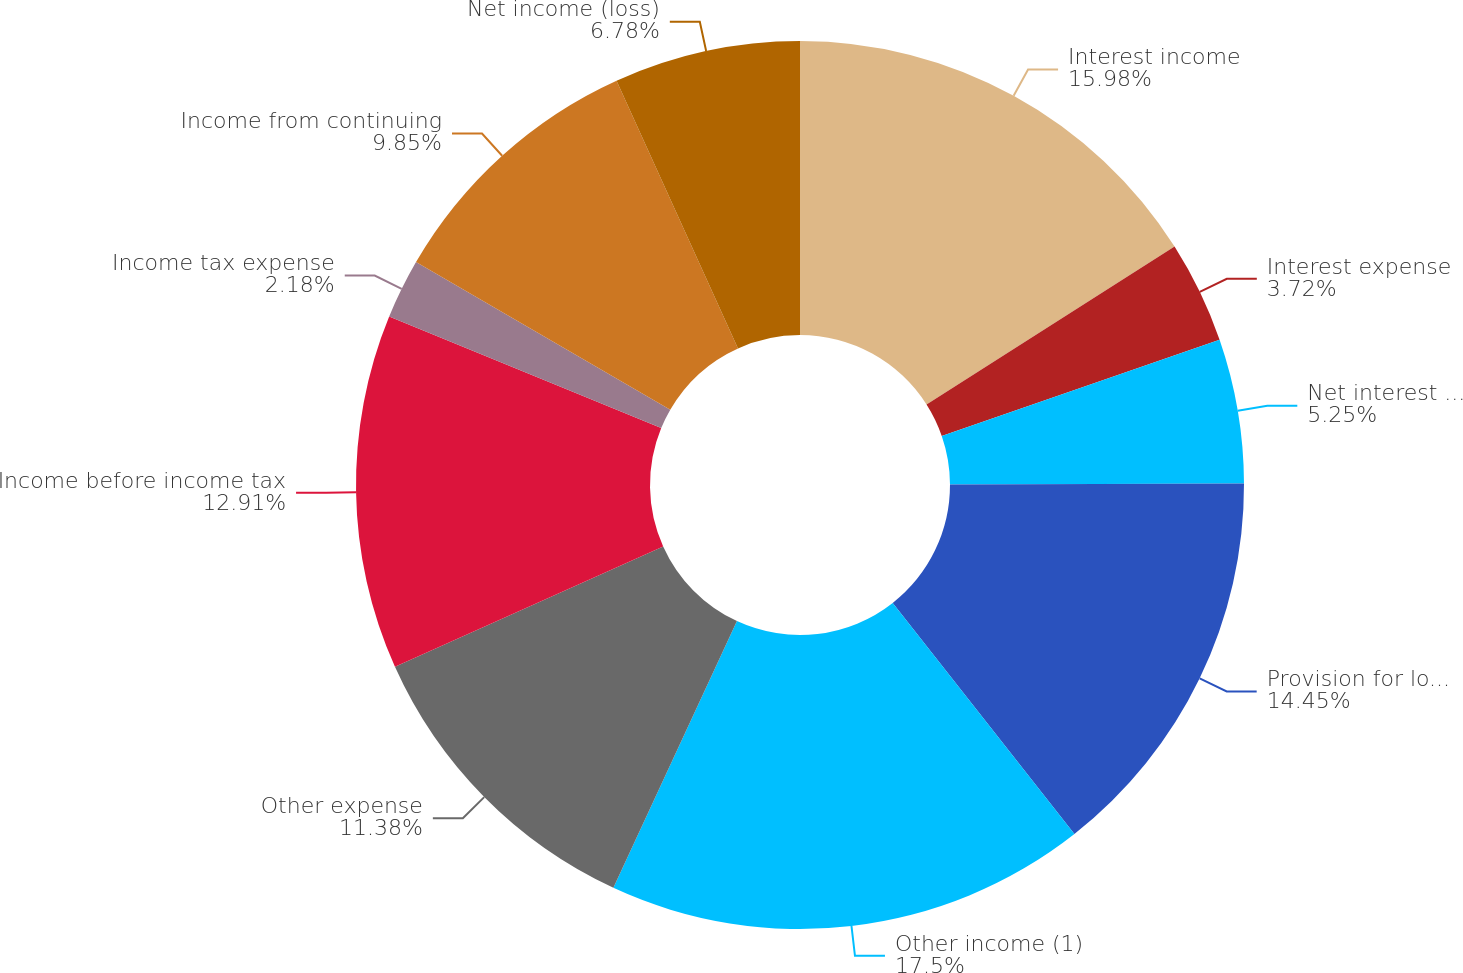Convert chart to OTSL. <chart><loc_0><loc_0><loc_500><loc_500><pie_chart><fcel>Interest income<fcel>Interest expense<fcel>Net interest income<fcel>Provision for loan losses<fcel>Other income (1)<fcel>Other expense<fcel>Income before income tax<fcel>Income tax expense<fcel>Income from continuing<fcel>Net income (loss)<nl><fcel>15.98%<fcel>3.72%<fcel>5.25%<fcel>14.45%<fcel>17.51%<fcel>11.38%<fcel>12.91%<fcel>2.18%<fcel>9.85%<fcel>6.78%<nl></chart> 